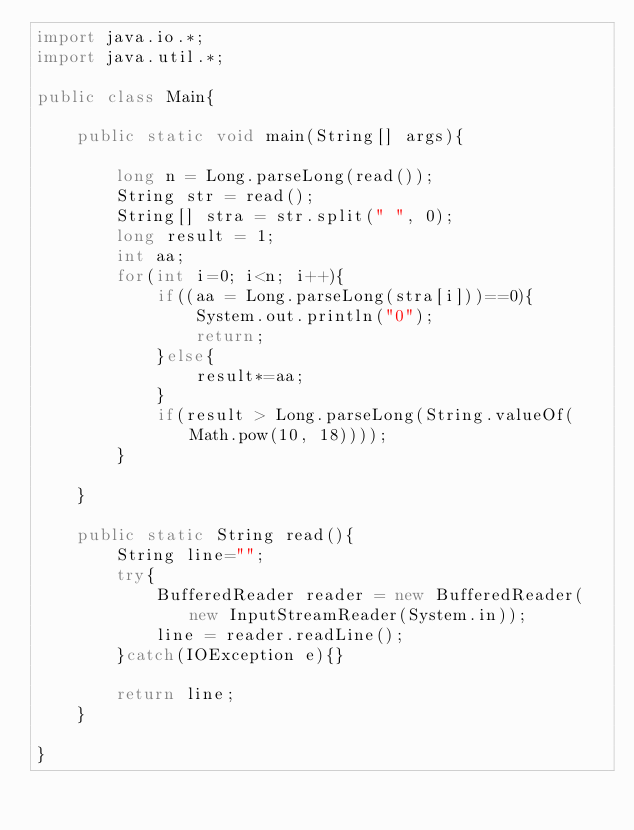<code> <loc_0><loc_0><loc_500><loc_500><_Java_>import java.io.*;
import java.util.*;

public class Main{

    public static void main(String[] args){

        long n = Long.parseLong(read());
        String str = read();
        String[] stra = str.split(" ", 0);
        long result = 1;
        int aa;
        for(int i=0; i<n; i++){
            if((aa = Long.parseLong(stra[i]))==0){
                System.out.println("0");
                return;
            }else{
                result*=aa;
            }
            if(result > Long.parseLong(String.valueOf(Math.pow(10, 18))));
        }

    }

    public static String read(){
        String line="";
        try{
            BufferedReader reader = new BufferedReader(new InputStreamReader(System.in));
            line = reader.readLine();
        }catch(IOException e){}
        
        return line;
    }

}</code> 